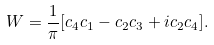<formula> <loc_0><loc_0><loc_500><loc_500>W = \frac { 1 } { \pi } [ c _ { 4 } c _ { 1 } - c _ { 2 } c _ { 3 } + i c _ { 2 } c _ { 4 } ] .</formula> 